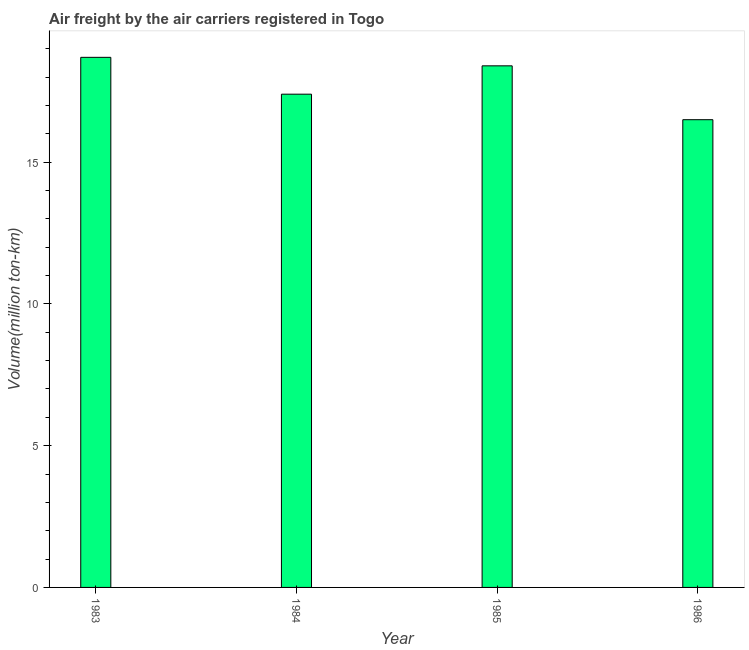What is the title of the graph?
Keep it short and to the point. Air freight by the air carriers registered in Togo. What is the label or title of the Y-axis?
Offer a very short reply. Volume(million ton-km). What is the air freight in 1985?
Your answer should be compact. 18.4. Across all years, what is the maximum air freight?
Your answer should be compact. 18.7. Across all years, what is the minimum air freight?
Offer a very short reply. 16.5. In which year was the air freight maximum?
Your response must be concise. 1983. In which year was the air freight minimum?
Your response must be concise. 1986. What is the sum of the air freight?
Your answer should be compact. 71. What is the average air freight per year?
Provide a succinct answer. 17.75. What is the median air freight?
Your response must be concise. 17.9. Do a majority of the years between 1986 and 1984 (inclusive) have air freight greater than 6 million ton-km?
Offer a very short reply. Yes. Is the air freight in 1983 less than that in 1984?
Offer a very short reply. No. Is the difference between the air freight in 1983 and 1985 greater than the difference between any two years?
Your answer should be very brief. No. Is the sum of the air freight in 1983 and 1986 greater than the maximum air freight across all years?
Make the answer very short. Yes. What is the difference between the highest and the lowest air freight?
Keep it short and to the point. 2.2. How many bars are there?
Ensure brevity in your answer.  4. Are all the bars in the graph horizontal?
Your answer should be compact. No. How many years are there in the graph?
Give a very brief answer. 4. What is the difference between two consecutive major ticks on the Y-axis?
Your response must be concise. 5. What is the Volume(million ton-km) of 1983?
Provide a short and direct response. 18.7. What is the Volume(million ton-km) of 1984?
Provide a short and direct response. 17.4. What is the Volume(million ton-km) of 1985?
Provide a short and direct response. 18.4. What is the difference between the Volume(million ton-km) in 1984 and 1985?
Make the answer very short. -1. What is the difference between the Volume(million ton-km) in 1985 and 1986?
Make the answer very short. 1.9. What is the ratio of the Volume(million ton-km) in 1983 to that in 1984?
Provide a succinct answer. 1.07. What is the ratio of the Volume(million ton-km) in 1983 to that in 1986?
Offer a very short reply. 1.13. What is the ratio of the Volume(million ton-km) in 1984 to that in 1985?
Offer a terse response. 0.95. What is the ratio of the Volume(million ton-km) in 1984 to that in 1986?
Ensure brevity in your answer.  1.05. What is the ratio of the Volume(million ton-km) in 1985 to that in 1986?
Provide a succinct answer. 1.11. 